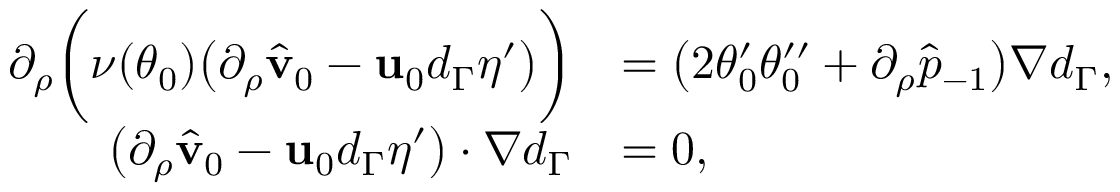<formula> <loc_0><loc_0><loc_500><loc_500>\begin{array} { r l } { \partial _ { \rho } \left ( \nu ( \theta _ { 0 } ) \left ( \partial _ { \rho } \hat { v } _ { 0 } - u _ { 0 } d _ { \Gamma } \eta ^ { \prime } \right ) \right ) } & { = \left ( 2 \theta _ { 0 } ^ { \prime } \theta _ { 0 } ^ { \prime \prime } + \partial _ { \rho } \hat { p } _ { - 1 } \right ) \nabla d _ { \Gamma } , } \\ { \left ( \partial _ { \rho } \hat { v } _ { 0 } - u _ { 0 } d _ { \Gamma } \eta ^ { \prime } \right ) \cdot \nabla d _ { \Gamma } } & { = 0 , } \end{array}</formula> 